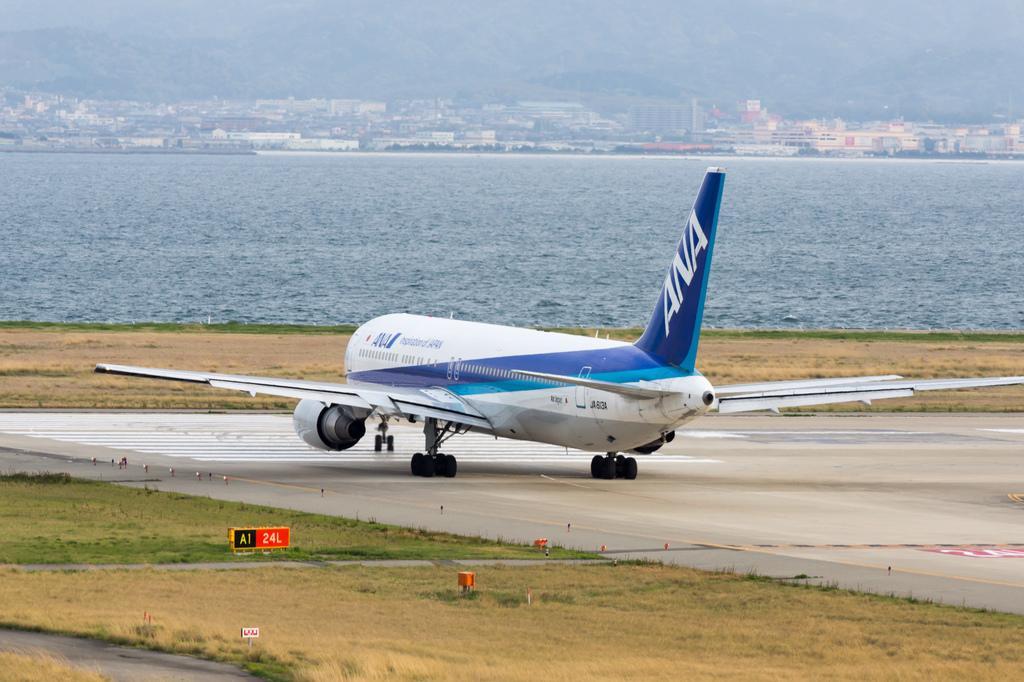Can you describe this image briefly? This is an outside view. In the middle of this image there is an aeroplane on the ground. At the bottom, I can see the grass. In the background, I can see the water. At the top of the image there are many trees and buildings. 